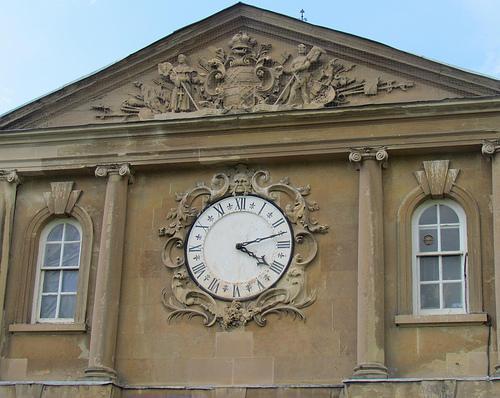How many glass make up each window?
Give a very brief answer. 8. How many windows are in the photo?
Give a very brief answer. 2. How many pillars are visible in the image?
Give a very brief answer. 2. 